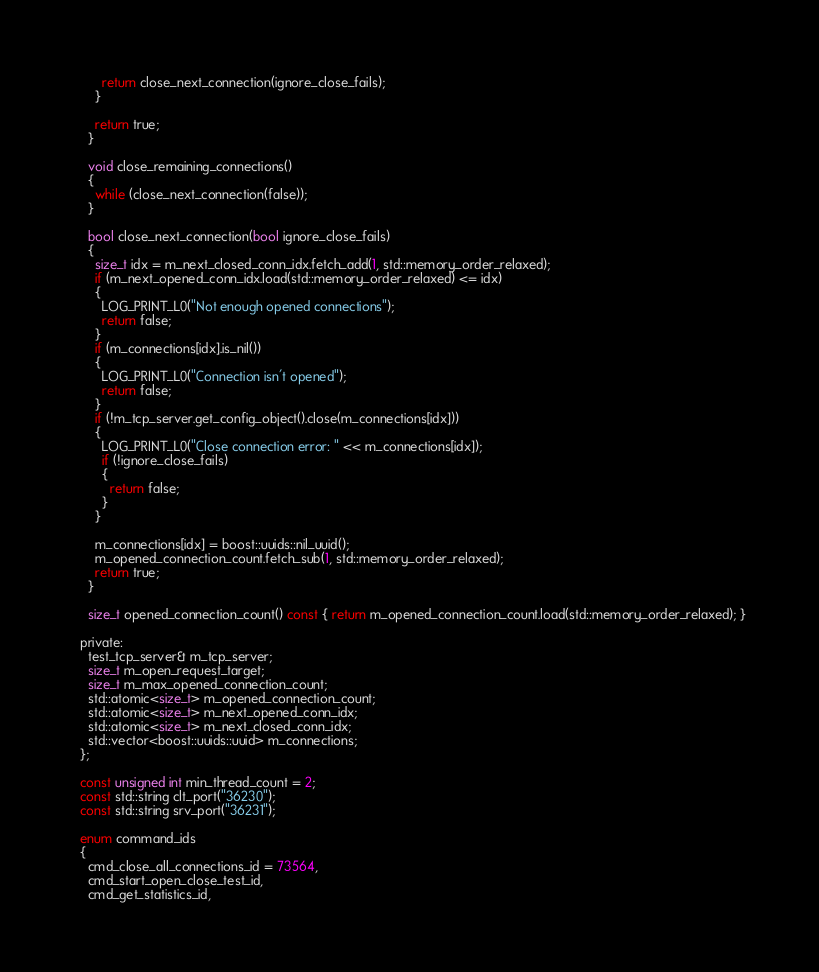<code> <loc_0><loc_0><loc_500><loc_500><_C_>        return close_next_connection(ignore_close_fails);
      }

      return true;
    }

    void close_remaining_connections()
    {
      while (close_next_connection(false));
    }

    bool close_next_connection(bool ignore_close_fails)
    {
      size_t idx = m_next_closed_conn_idx.fetch_add(1, std::memory_order_relaxed);
      if (m_next_opened_conn_idx.load(std::memory_order_relaxed) <= idx)
      {
        LOG_PRINT_L0("Not enough opened connections");
        return false;
      }
      if (m_connections[idx].is_nil())
      {
        LOG_PRINT_L0("Connection isn't opened");
        return false;
      }
      if (!m_tcp_server.get_config_object().close(m_connections[idx]))
      {
        LOG_PRINT_L0("Close connection error: " << m_connections[idx]);
        if (!ignore_close_fails)
        {
          return false;
        }
      }

      m_connections[idx] = boost::uuids::nil_uuid();
      m_opened_connection_count.fetch_sub(1, std::memory_order_relaxed);
      return true;
    }

    size_t opened_connection_count() const { return m_opened_connection_count.load(std::memory_order_relaxed); }

  private:
    test_tcp_server& m_tcp_server;
    size_t m_open_request_target;
    size_t m_max_opened_connection_count;
    std::atomic<size_t> m_opened_connection_count;
    std::atomic<size_t> m_next_opened_conn_idx;
    std::atomic<size_t> m_next_closed_conn_idx;
    std::vector<boost::uuids::uuid> m_connections;
  };

  const unsigned int min_thread_count = 2;
  const std::string clt_port("36230");
  const std::string srv_port("36231");

  enum command_ids
  {
    cmd_close_all_connections_id = 73564,
    cmd_start_open_close_test_id,
    cmd_get_statistics_id,</code> 